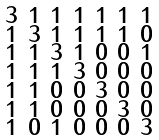<formula> <loc_0><loc_0><loc_500><loc_500>\begin{smallmatrix} 3 & 1 & 1 & 1 & 1 & 1 & 1 \\ 1 & 3 & 1 & 1 & 1 & 1 & 0 \\ 1 & 1 & 3 & 1 & 0 & 0 & 1 \\ 1 & 1 & 1 & 3 & 0 & 0 & 0 \\ 1 & 1 & 0 & 0 & 3 & 0 & 0 \\ 1 & 1 & 0 & 0 & 0 & 3 & 0 \\ 1 & 0 & 1 & 0 & 0 & 0 & 3 \end{smallmatrix}</formula> 